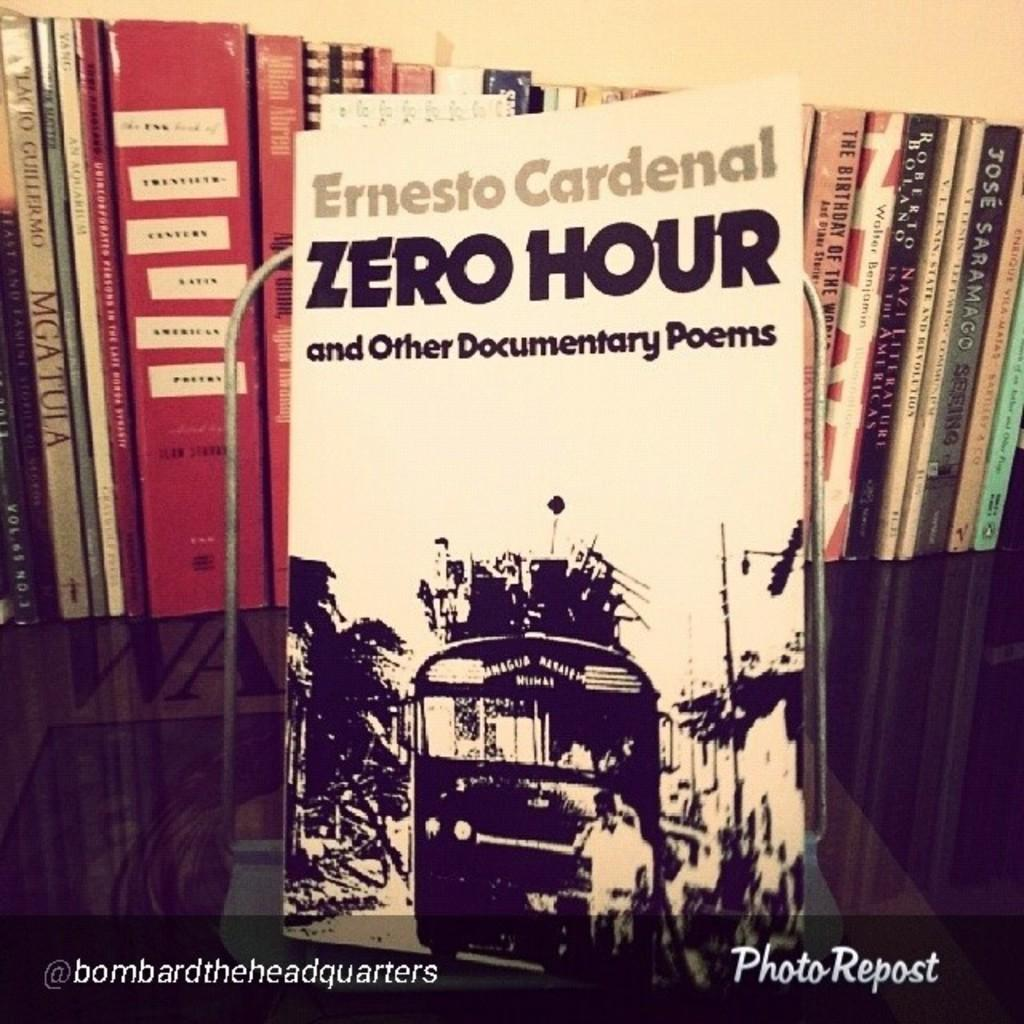Provide a one-sentence caption for the provided image. A book called Zero Hour is on a shelf with other books. 